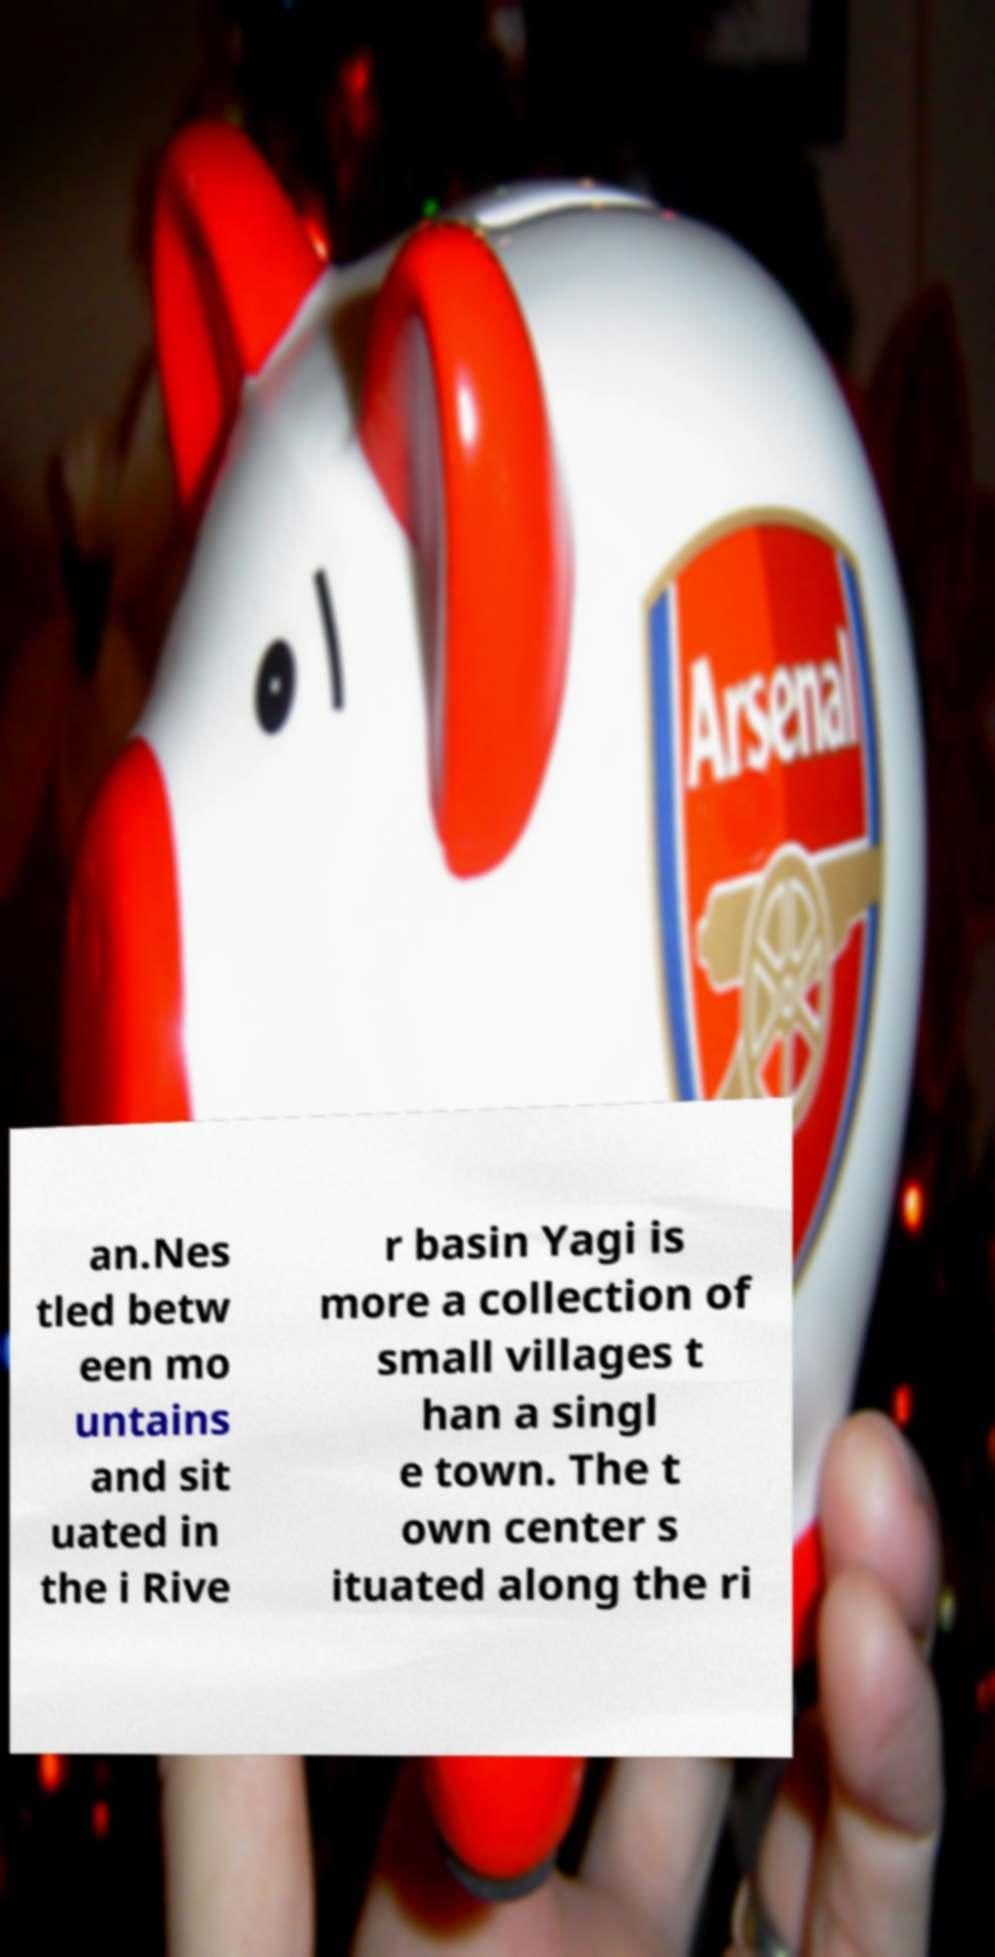Could you assist in decoding the text presented in this image and type it out clearly? an.Nes tled betw een mo untains and sit uated in the i Rive r basin Yagi is more a collection of small villages t han a singl e town. The t own center s ituated along the ri 